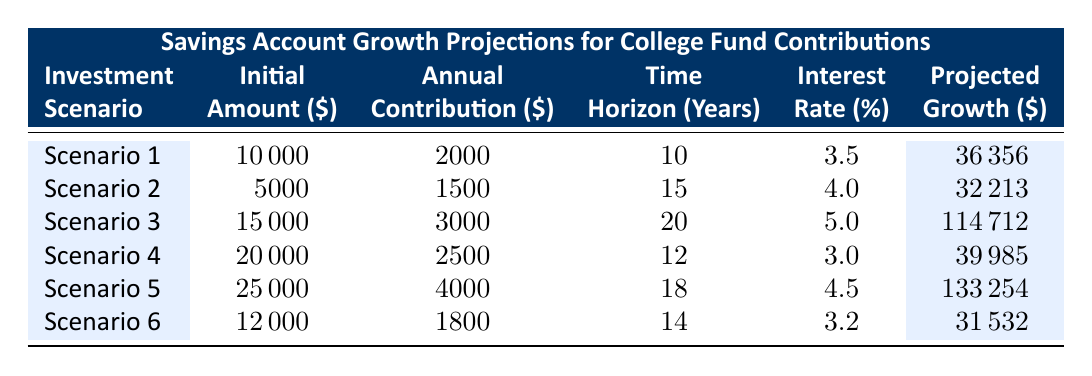What is the projected growth for Scenario 3? Referring directly to the table, the projected growth for Scenario 3 is listed under the "Projected Growth" column. For Scenario 3, it is $114712.
Answer: 114712 How many years is the time horizon for Scenario 2? Looking at the table, the time horizon for Scenario 2 is in the "Time Horizon (Years)" column. It shows 15 years.
Answer: 15 Which scenario has the highest initial investment amount? By comparing the "Initial Amount ($)" column for all scenarios, Scenario 5 has the highest initial investment amount of $25000.
Answer: 25000 What is the total projected growth from Scenario 1 and Scenario 4 combined? To find the total projected growth, we add the projected growth values for Scenario 1 ($36356) and Scenario 4 ($39985) together: 36356 + 39985 = 76341.
Answer: 76341 Is the interest rate for Scenario 6 lower than that for Scenario 2? Checking the "Interest Rate (%)" column, Scenario 6 has an interest rate of 3.2%, while Scenario 2 has an interest rate of 4.0%. Since 3.2% is less than 4.0%, the statement is true.
Answer: Yes Which scenario has both an annual contribution and time horizon greater than 20? None of the scenarios have both an annual contribution greater than $2000 and a time horizon greater than 20 years. The maximum time horizon is 20 years (Scenario 3), and the maximum annual contribution is $4000 (Scenario 5), so none meet both criteria.
Answer: No What is the difference in projected growth between Scenario 5 and Scenario 3? From the table, Scenario 5 has a projected growth of $133254, and Scenario 3 has a projected growth of $114712. To find the difference: 133254 - 114712 = 18642.
Answer: 18642 What is the average initial investment across all scenarios? To calculate the average initial investment, add all the initial amounts: (10000 + 5000 + 15000 + 20000 + 25000 + 12000) = 100000. Then divide by the number of scenarios, which is 6: 100000 / 6 = 16666.67.
Answer: 16666.67 How many scenarios have an annual contribution of at least $2500? By examining the "Annual Contribution ($)" column, Scenarios 3, 4, and 5 have annual contributions of $3000, $2500, and $4000 respectively. There are a total of 3 scenarios that meet this criterion.
Answer: 3 